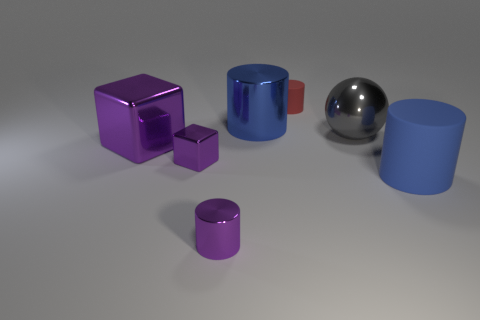Is the gray metallic object the same size as the purple cylinder?
Your answer should be compact. No. There is a rubber thing to the right of the gray sphere; is its size the same as the big metallic cube?
Give a very brief answer. Yes. What is the color of the large cylinder that is in front of the big blue shiny thing?
Offer a very short reply. Blue. What number of red cylinders are there?
Your answer should be very brief. 1. There is a blue thing that is made of the same material as the big gray sphere; what is its shape?
Provide a succinct answer. Cylinder. There is a big metal object that is in front of the large gray ball; is it the same color as the rubber cylinder in front of the big purple object?
Your answer should be compact. No. Is the number of big blue metal objects in front of the large blue shiny thing the same as the number of big red spheres?
Offer a very short reply. Yes. What number of gray balls are behind the red object?
Keep it short and to the point. 0. How big is the gray shiny sphere?
Your response must be concise. Large. What is the color of the other large thing that is the same material as the red object?
Your response must be concise. Blue. 